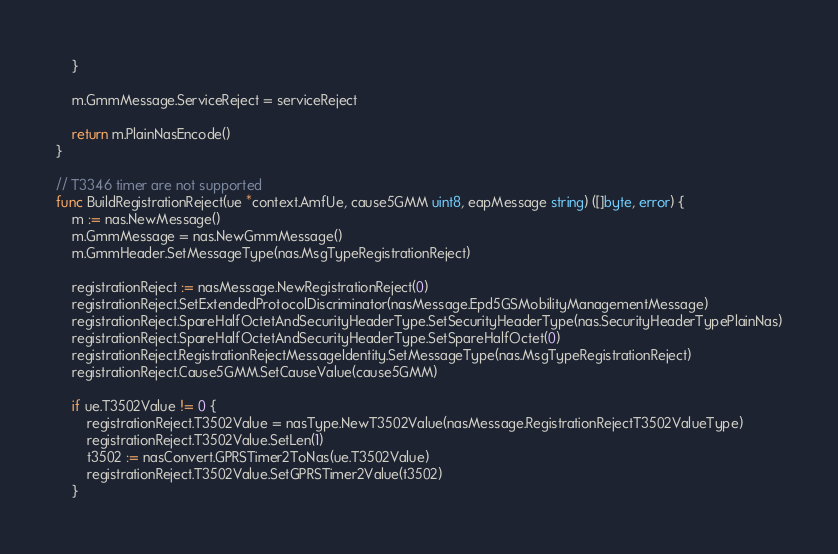Convert code to text. <code><loc_0><loc_0><loc_500><loc_500><_Go_>	}

	m.GmmMessage.ServiceReject = serviceReject

	return m.PlainNasEncode()
}

// T3346 timer are not supported
func BuildRegistrationReject(ue *context.AmfUe, cause5GMM uint8, eapMessage string) ([]byte, error) {
	m := nas.NewMessage()
	m.GmmMessage = nas.NewGmmMessage()
	m.GmmHeader.SetMessageType(nas.MsgTypeRegistrationReject)

	registrationReject := nasMessage.NewRegistrationReject(0)
	registrationReject.SetExtendedProtocolDiscriminator(nasMessage.Epd5GSMobilityManagementMessage)
	registrationReject.SpareHalfOctetAndSecurityHeaderType.SetSecurityHeaderType(nas.SecurityHeaderTypePlainNas)
	registrationReject.SpareHalfOctetAndSecurityHeaderType.SetSpareHalfOctet(0)
	registrationReject.RegistrationRejectMessageIdentity.SetMessageType(nas.MsgTypeRegistrationReject)
	registrationReject.Cause5GMM.SetCauseValue(cause5GMM)

	if ue.T3502Value != 0 {
		registrationReject.T3502Value = nasType.NewT3502Value(nasMessage.RegistrationRejectT3502ValueType)
		registrationReject.T3502Value.SetLen(1)
		t3502 := nasConvert.GPRSTimer2ToNas(ue.T3502Value)
		registrationReject.T3502Value.SetGPRSTimer2Value(t3502)
	}
</code> 